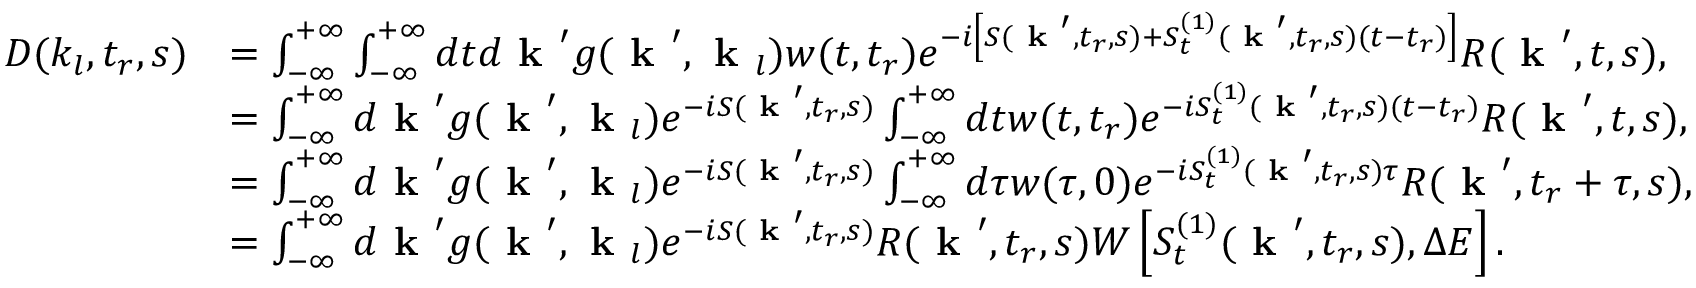Convert formula to latex. <formula><loc_0><loc_0><loc_500><loc_500>\begin{array} { r l } { D ( k _ { l } , t _ { r } , s ) } & { = \int _ { - \infty } ^ { + \infty } \int _ { - \infty } ^ { + \infty } d t d k ^ { \prime } g ( k ^ { \prime } , k _ { l } ) w ( t , t _ { r } ) e ^ { - i \left [ S ( k ^ { \prime } , t _ { r } , s ) + S _ { t } ^ { ( 1 ) } ( k ^ { \prime } , t _ { r } , s ) ( t - t _ { r } ) \right ] } R ( k ^ { \prime } , t , s ) , } \\ & { = \int _ { - \infty } ^ { + \infty } d k ^ { \prime } g ( k ^ { \prime } , k _ { l } ) e ^ { - i S ( k ^ { \prime } , t _ { r } , s ) } \int _ { - \infty } ^ { + \infty } d t w ( t , t _ { r } ) e ^ { - i S _ { t } ^ { ( 1 ) } ( k ^ { \prime } , t _ { r } , s ) ( t - t _ { r } ) } R ( k ^ { \prime } , t , s ) , } \\ & { = \int _ { - \infty } ^ { + \infty } d k ^ { \prime } g ( k ^ { \prime } , k _ { l } ) e ^ { - i S ( k ^ { \prime } , t _ { r } , s ) } \int _ { - \infty } ^ { + \infty } d \tau w ( \tau , 0 ) e ^ { - i S _ { t } ^ { ( 1 ) } ( k ^ { \prime } , t _ { r } , s ) \tau } R ( k ^ { \prime } , t _ { r } + \tau , s ) , } \\ & { = \int _ { - \infty } ^ { + \infty } d k ^ { \prime } g ( k ^ { \prime } , k _ { l } ) e ^ { - i S ( k ^ { \prime } , t _ { r } , s ) } R ( k ^ { \prime } , t _ { r } , s ) W \left [ S _ { t } ^ { ( 1 ) } ( k ^ { \prime } , t _ { r } , s ) , \Delta E \right ] . } \end{array}</formula> 